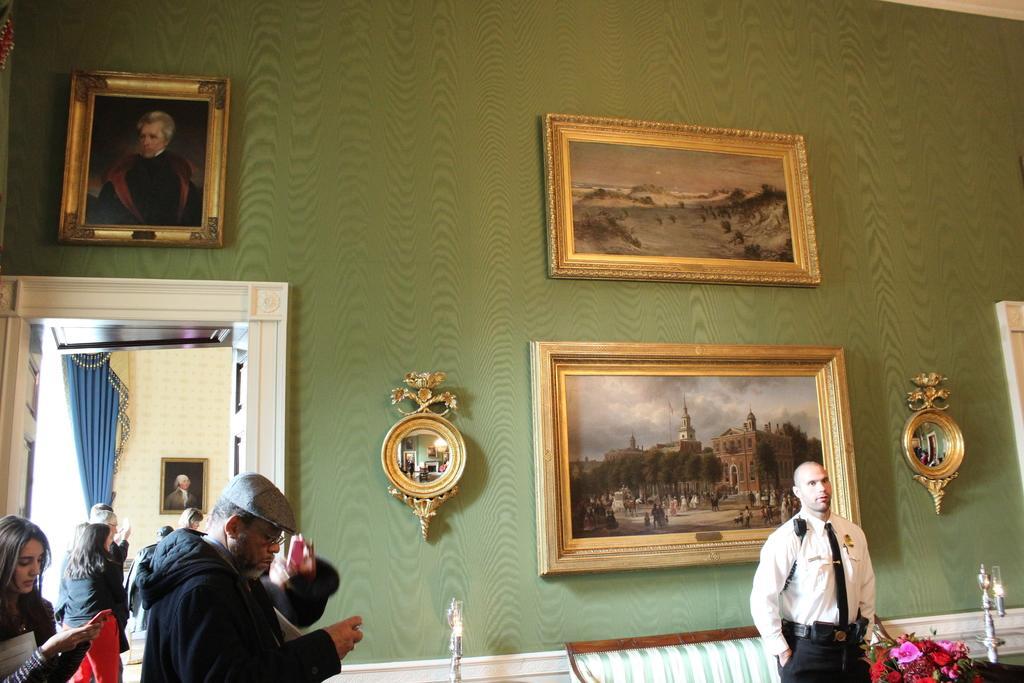Describe this image in one or two sentences. In this image I can see few people are standing. I can see one of them is wearing an uniform. I can also see few flowers, few lights, door, blue color curtain and I can see few frames in these walls. I can also see few things on this wall. 